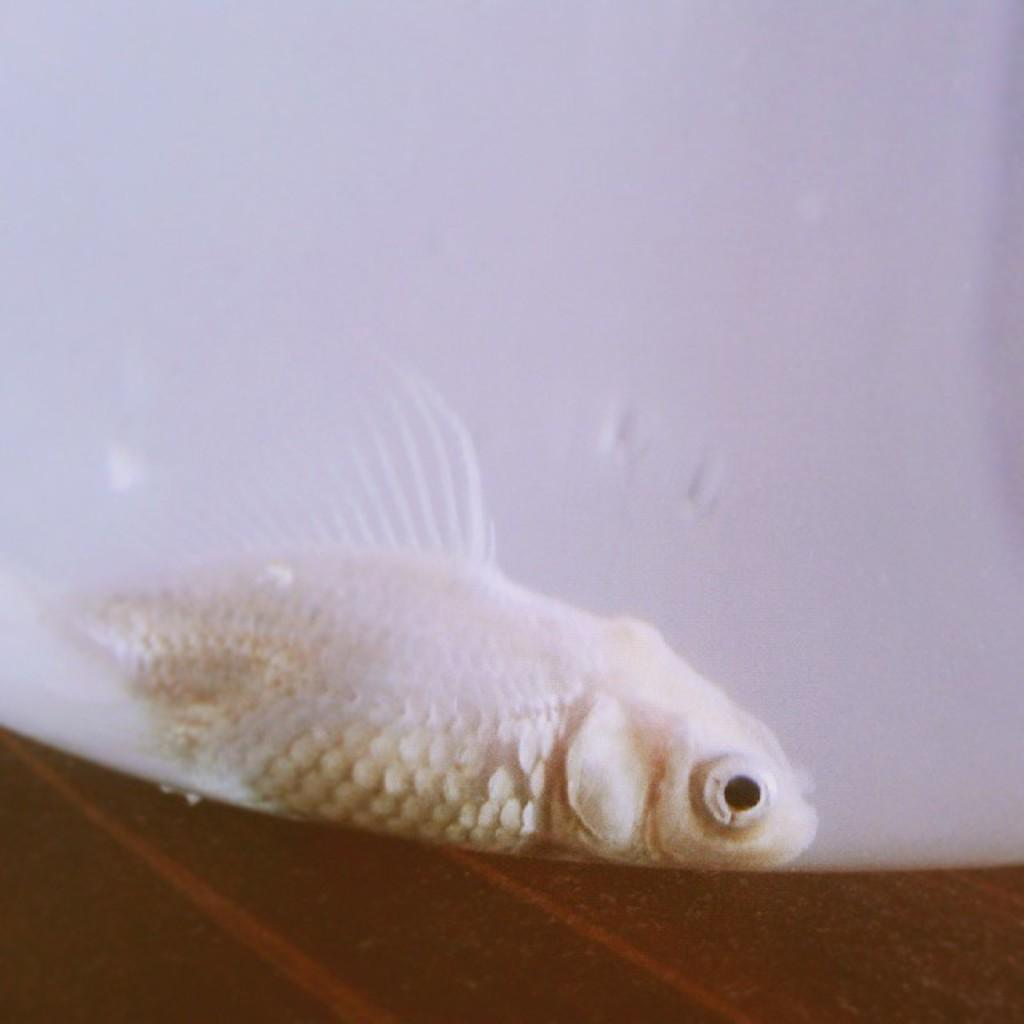What type of animal is in the image? There is a white color fish in the image. Where is the fish located in the image? The fish is at the bottom of the image. What color is the wall in the background of the image? The wall in the background of the image is white. What type of road can be seen in the image? There is no road present in the image; it features a white color fish at the bottom and a white color wall in the background. 